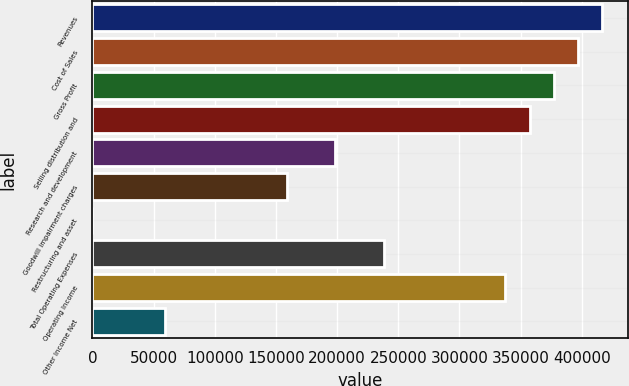<chart> <loc_0><loc_0><loc_500><loc_500><bar_chart><fcel>Revenues<fcel>Cost of Sales<fcel>Gross Profit<fcel>Selling distribution and<fcel>Research and development<fcel>Goodwill impairment charges<fcel>Restructuring and asset<fcel>Total Operating Expenses<fcel>Operating Income<fcel>Other Income Net<nl><fcel>416900<fcel>397048<fcel>377196<fcel>357345<fcel>198533<fcel>158830<fcel>18<fcel>238236<fcel>337494<fcel>59572.5<nl></chart> 